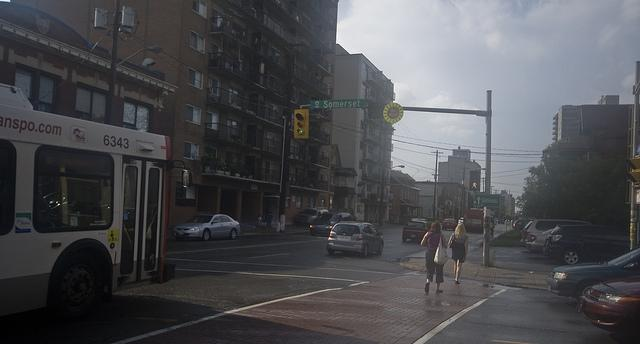Why is the street shiny? Please explain your reasoning. just rained. The surface is shiny due to wetness, because it has recently rained. 